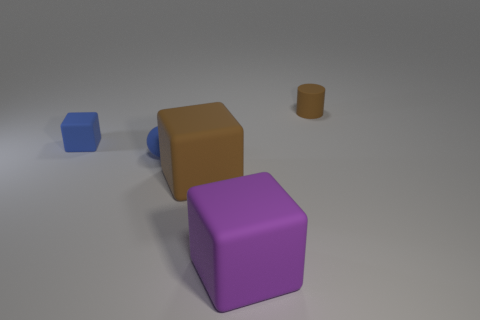There is a tiny rubber object that is in front of the tiny block on the left side of the large brown rubber thing; what color is it?
Provide a succinct answer. Blue. There is a object on the left side of the blue matte thing that is in front of the matte thing that is on the left side of the tiny blue matte ball; what is it made of?
Make the answer very short. Rubber. How many blue matte blocks have the same size as the purple rubber object?
Give a very brief answer. 0. There is a small object that is in front of the small brown thing and to the right of the small block; what is its material?
Your answer should be very brief. Rubber. How many big objects are on the right side of the blue rubber ball?
Offer a very short reply. 2. Does the large brown matte object have the same shape as the matte object that is left of the tiny sphere?
Offer a very short reply. Yes. Are there any other large brown matte things of the same shape as the large brown object?
Provide a succinct answer. No. What shape is the brown thing that is in front of the brown thing that is on the right side of the large brown matte thing?
Keep it short and to the point. Cube. There is a brown object that is right of the big purple matte block; what is its shape?
Your response must be concise. Cylinder. Is the color of the small rubber thing on the left side of the small sphere the same as the block that is on the right side of the large brown cube?
Keep it short and to the point. No. 